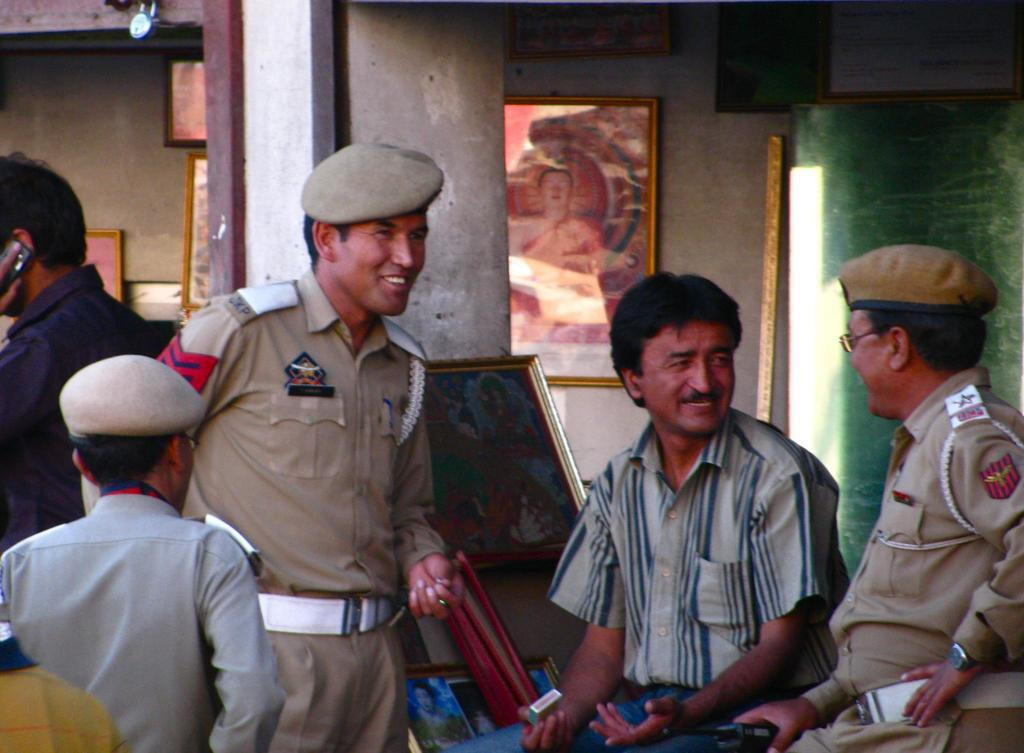How many people are in the image? There is a group of people in the image, but the exact number is not specified. What are some of the people wearing? Some of the people in the image are wearing uniforms. What objects can be seen in the image besides the people? There are photo frames, a pillar, and a wall visible in the image. What is located at the top of the image? There is a lock at the top of the image. What songs are being sung by the people in the image? There is no indication in the image that the people are singing songs, so it cannot be determined from the picture. 